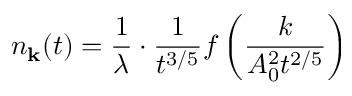Convert formula to latex. <formula><loc_0><loc_0><loc_500><loc_500>n _ { k } ( t ) = { \frac { 1 } { \lambda } } \cdot { \frac { 1 } { t ^ { 3 / 5 } } } f \left ( { \frac { k } { A _ { 0 } ^ { 2 } t ^ { 2 / 5 } } } \right )</formula> 